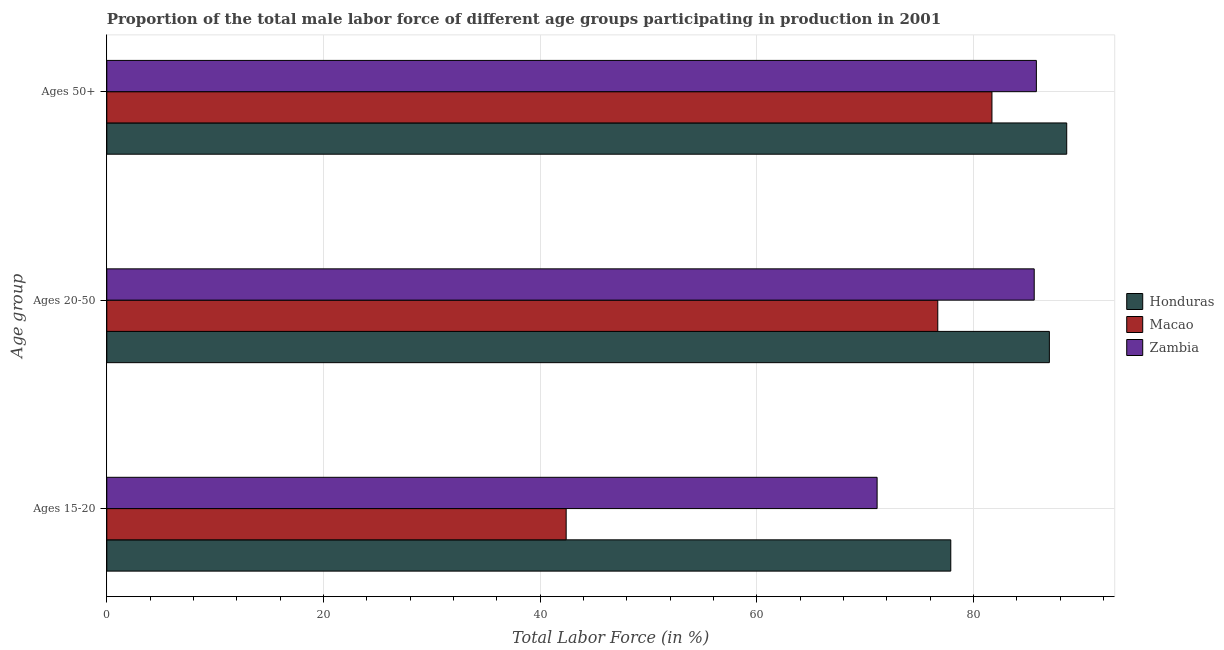How many groups of bars are there?
Your answer should be very brief. 3. Are the number of bars per tick equal to the number of legend labels?
Provide a succinct answer. Yes. Are the number of bars on each tick of the Y-axis equal?
Keep it short and to the point. Yes. What is the label of the 2nd group of bars from the top?
Keep it short and to the point. Ages 20-50. What is the percentage of male labor force within the age group 15-20 in Macao?
Your answer should be compact. 42.4. Across all countries, what is the minimum percentage of male labor force within the age group 15-20?
Offer a very short reply. 42.4. In which country was the percentage of male labor force above age 50 maximum?
Ensure brevity in your answer.  Honduras. In which country was the percentage of male labor force above age 50 minimum?
Ensure brevity in your answer.  Macao. What is the total percentage of male labor force above age 50 in the graph?
Your answer should be very brief. 256.1. What is the difference between the percentage of male labor force within the age group 20-50 in Honduras and that in Zambia?
Provide a short and direct response. 1.4. What is the difference between the percentage of male labor force within the age group 20-50 in Honduras and the percentage of male labor force within the age group 15-20 in Zambia?
Your response must be concise. 15.9. What is the average percentage of male labor force within the age group 20-50 per country?
Your answer should be compact. 83.1. What is the difference between the percentage of male labor force above age 50 and percentage of male labor force within the age group 20-50 in Honduras?
Offer a terse response. 1.6. In how many countries, is the percentage of male labor force within the age group 15-20 greater than 40 %?
Your answer should be compact. 3. What is the ratio of the percentage of male labor force above age 50 in Macao to that in Zambia?
Make the answer very short. 0.95. What is the difference between the highest and the second highest percentage of male labor force within the age group 15-20?
Keep it short and to the point. 6.8. What is the difference between the highest and the lowest percentage of male labor force within the age group 15-20?
Provide a succinct answer. 35.5. In how many countries, is the percentage of male labor force within the age group 15-20 greater than the average percentage of male labor force within the age group 15-20 taken over all countries?
Provide a short and direct response. 2. Is the sum of the percentage of male labor force within the age group 15-20 in Macao and Zambia greater than the maximum percentage of male labor force above age 50 across all countries?
Your response must be concise. Yes. What does the 2nd bar from the top in Ages 20-50 represents?
Keep it short and to the point. Macao. What does the 3rd bar from the bottom in Ages 20-50 represents?
Offer a very short reply. Zambia. How many bars are there?
Provide a short and direct response. 9. Are all the bars in the graph horizontal?
Offer a very short reply. Yes. How many countries are there in the graph?
Your answer should be very brief. 3. Are the values on the major ticks of X-axis written in scientific E-notation?
Offer a terse response. No. Does the graph contain grids?
Your answer should be very brief. Yes. How many legend labels are there?
Keep it short and to the point. 3. What is the title of the graph?
Provide a short and direct response. Proportion of the total male labor force of different age groups participating in production in 2001. What is the label or title of the Y-axis?
Your answer should be very brief. Age group. What is the Total Labor Force (in %) of Honduras in Ages 15-20?
Keep it short and to the point. 77.9. What is the Total Labor Force (in %) of Macao in Ages 15-20?
Give a very brief answer. 42.4. What is the Total Labor Force (in %) of Zambia in Ages 15-20?
Keep it short and to the point. 71.1. What is the Total Labor Force (in %) of Macao in Ages 20-50?
Give a very brief answer. 76.7. What is the Total Labor Force (in %) in Zambia in Ages 20-50?
Your response must be concise. 85.6. What is the Total Labor Force (in %) in Honduras in Ages 50+?
Give a very brief answer. 88.6. What is the Total Labor Force (in %) of Macao in Ages 50+?
Your answer should be very brief. 81.7. What is the Total Labor Force (in %) of Zambia in Ages 50+?
Make the answer very short. 85.8. Across all Age group, what is the maximum Total Labor Force (in %) in Honduras?
Your response must be concise. 88.6. Across all Age group, what is the maximum Total Labor Force (in %) in Macao?
Your answer should be very brief. 81.7. Across all Age group, what is the maximum Total Labor Force (in %) in Zambia?
Your response must be concise. 85.8. Across all Age group, what is the minimum Total Labor Force (in %) in Honduras?
Give a very brief answer. 77.9. Across all Age group, what is the minimum Total Labor Force (in %) in Macao?
Your answer should be compact. 42.4. Across all Age group, what is the minimum Total Labor Force (in %) in Zambia?
Provide a short and direct response. 71.1. What is the total Total Labor Force (in %) of Honduras in the graph?
Your answer should be compact. 253.5. What is the total Total Labor Force (in %) in Macao in the graph?
Offer a very short reply. 200.8. What is the total Total Labor Force (in %) in Zambia in the graph?
Your response must be concise. 242.5. What is the difference between the Total Labor Force (in %) of Macao in Ages 15-20 and that in Ages 20-50?
Ensure brevity in your answer.  -34.3. What is the difference between the Total Labor Force (in %) in Zambia in Ages 15-20 and that in Ages 20-50?
Offer a terse response. -14.5. What is the difference between the Total Labor Force (in %) of Honduras in Ages 15-20 and that in Ages 50+?
Your answer should be very brief. -10.7. What is the difference between the Total Labor Force (in %) in Macao in Ages 15-20 and that in Ages 50+?
Your answer should be very brief. -39.3. What is the difference between the Total Labor Force (in %) in Zambia in Ages 15-20 and that in Ages 50+?
Ensure brevity in your answer.  -14.7. What is the difference between the Total Labor Force (in %) in Macao in Ages 20-50 and that in Ages 50+?
Provide a short and direct response. -5. What is the difference between the Total Labor Force (in %) of Zambia in Ages 20-50 and that in Ages 50+?
Offer a very short reply. -0.2. What is the difference between the Total Labor Force (in %) in Honduras in Ages 15-20 and the Total Labor Force (in %) in Zambia in Ages 20-50?
Ensure brevity in your answer.  -7.7. What is the difference between the Total Labor Force (in %) in Macao in Ages 15-20 and the Total Labor Force (in %) in Zambia in Ages 20-50?
Make the answer very short. -43.2. What is the difference between the Total Labor Force (in %) of Macao in Ages 15-20 and the Total Labor Force (in %) of Zambia in Ages 50+?
Provide a short and direct response. -43.4. What is the difference between the Total Labor Force (in %) in Honduras in Ages 20-50 and the Total Labor Force (in %) in Macao in Ages 50+?
Provide a short and direct response. 5.3. What is the average Total Labor Force (in %) of Honduras per Age group?
Provide a succinct answer. 84.5. What is the average Total Labor Force (in %) of Macao per Age group?
Make the answer very short. 66.93. What is the average Total Labor Force (in %) of Zambia per Age group?
Offer a terse response. 80.83. What is the difference between the Total Labor Force (in %) of Honduras and Total Labor Force (in %) of Macao in Ages 15-20?
Ensure brevity in your answer.  35.5. What is the difference between the Total Labor Force (in %) in Honduras and Total Labor Force (in %) in Zambia in Ages 15-20?
Make the answer very short. 6.8. What is the difference between the Total Labor Force (in %) in Macao and Total Labor Force (in %) in Zambia in Ages 15-20?
Your response must be concise. -28.7. What is the difference between the Total Labor Force (in %) of Honduras and Total Labor Force (in %) of Macao in Ages 20-50?
Ensure brevity in your answer.  10.3. What is the difference between the Total Labor Force (in %) of Honduras and Total Labor Force (in %) of Zambia in Ages 20-50?
Offer a very short reply. 1.4. What is the difference between the Total Labor Force (in %) in Macao and Total Labor Force (in %) in Zambia in Ages 20-50?
Offer a terse response. -8.9. What is the difference between the Total Labor Force (in %) of Honduras and Total Labor Force (in %) of Zambia in Ages 50+?
Your response must be concise. 2.8. What is the difference between the Total Labor Force (in %) in Macao and Total Labor Force (in %) in Zambia in Ages 50+?
Give a very brief answer. -4.1. What is the ratio of the Total Labor Force (in %) of Honduras in Ages 15-20 to that in Ages 20-50?
Give a very brief answer. 0.9. What is the ratio of the Total Labor Force (in %) in Macao in Ages 15-20 to that in Ages 20-50?
Ensure brevity in your answer.  0.55. What is the ratio of the Total Labor Force (in %) in Zambia in Ages 15-20 to that in Ages 20-50?
Give a very brief answer. 0.83. What is the ratio of the Total Labor Force (in %) of Honduras in Ages 15-20 to that in Ages 50+?
Make the answer very short. 0.88. What is the ratio of the Total Labor Force (in %) in Macao in Ages 15-20 to that in Ages 50+?
Your answer should be very brief. 0.52. What is the ratio of the Total Labor Force (in %) in Zambia in Ages 15-20 to that in Ages 50+?
Offer a terse response. 0.83. What is the ratio of the Total Labor Force (in %) of Honduras in Ages 20-50 to that in Ages 50+?
Your answer should be compact. 0.98. What is the ratio of the Total Labor Force (in %) in Macao in Ages 20-50 to that in Ages 50+?
Your answer should be compact. 0.94. What is the ratio of the Total Labor Force (in %) of Zambia in Ages 20-50 to that in Ages 50+?
Make the answer very short. 1. What is the difference between the highest and the second highest Total Labor Force (in %) of Macao?
Keep it short and to the point. 5. What is the difference between the highest and the lowest Total Labor Force (in %) in Honduras?
Make the answer very short. 10.7. What is the difference between the highest and the lowest Total Labor Force (in %) of Macao?
Your response must be concise. 39.3. 